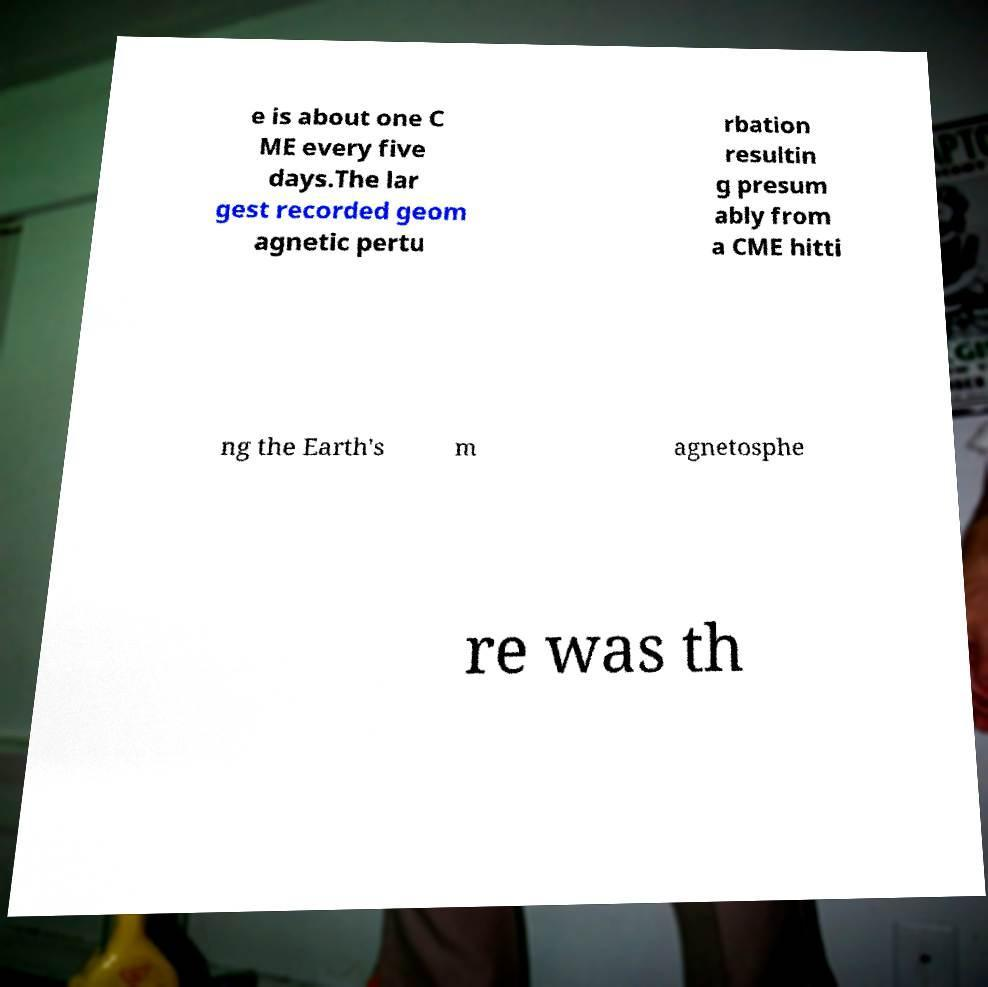I need the written content from this picture converted into text. Can you do that? e is about one C ME every five days.The lar gest recorded geom agnetic pertu rbation resultin g presum ably from a CME hitti ng the Earth's m agnetosphe re was th 